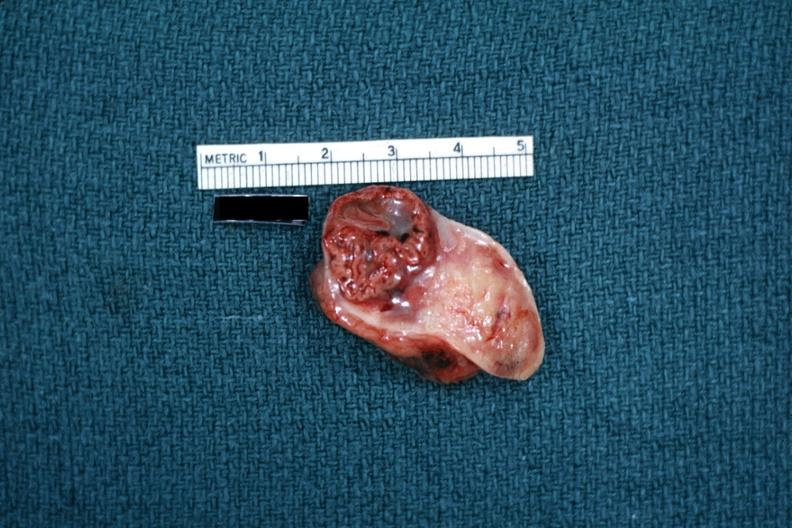s another fiber other frame present?
Answer the question using a single word or phrase. No 